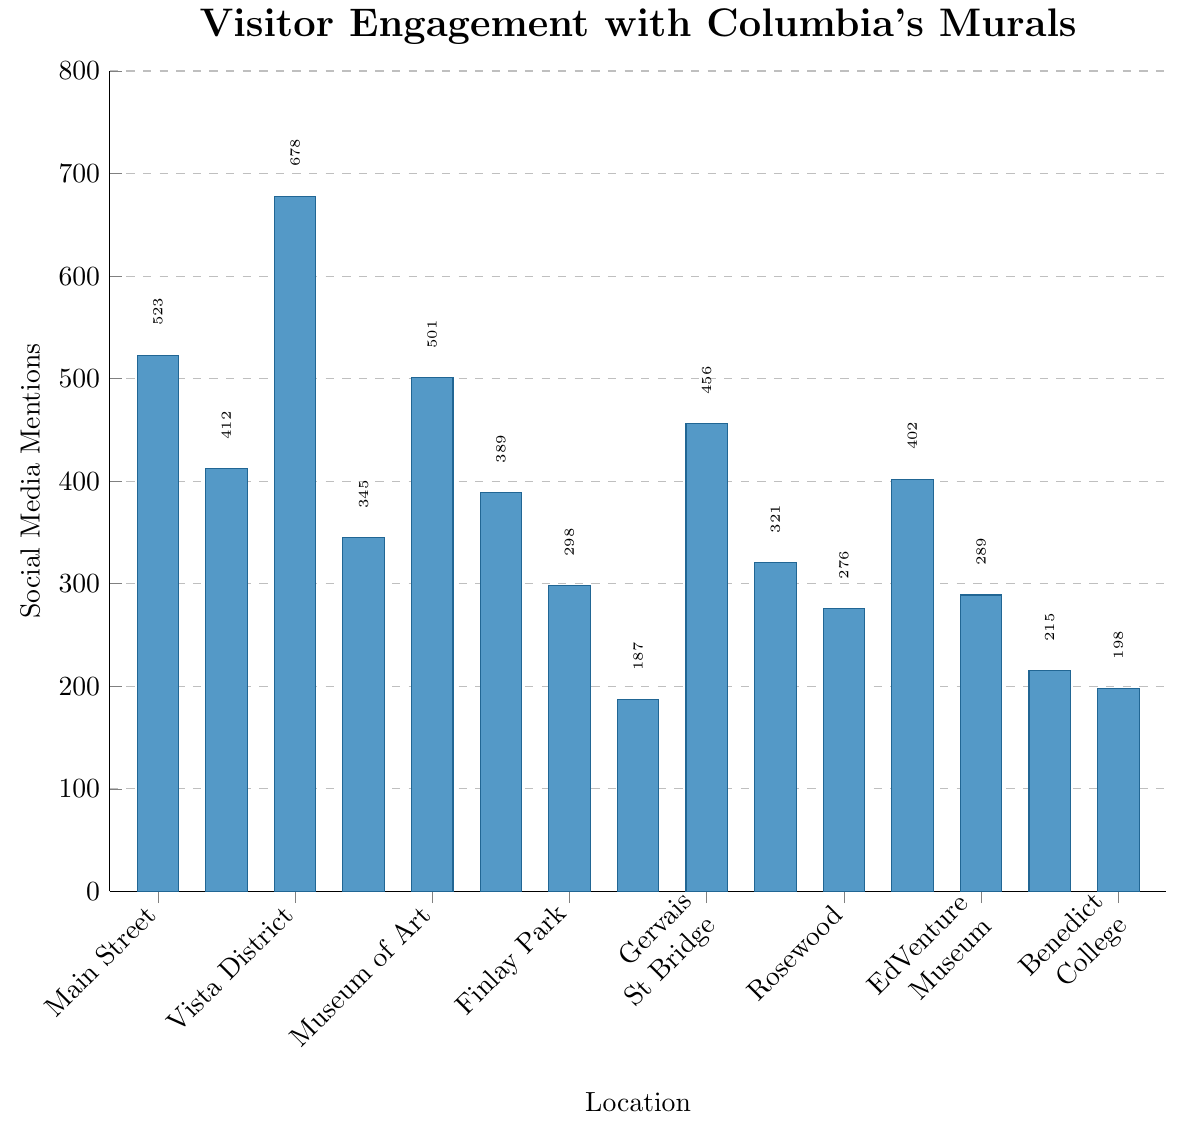what location has the highest number of social media mentions? The bar for Vista District Mural is the tallest, indicating that it has the highest number of mentions, which is 678.
Answer: Vista District Mural which location has the fewest social media mentions? The bar for Trenholm Plaza Public Art is the shortest, indicating that it has the fewest number of mentions, which is 187.
Answer: Trenholm Plaza Public Art what is the difference in social media mentions between the Main Street Mural and the Riverfront Park Installation? The number of mentions for Main Street Mural is 523 and for Riverfront Park Installation is 345. So, the difference is 523 - 345.
Answer: 178 which has more mentions, the EdVenture Children's Museum Exterior or Allen University Heritage Wall? By comparing the heights of the bars, EdVenture Children's Museum Exterior has 289 mentions, whereas Allen University Heritage Wall has 215 mentions. Thus, EdVenture Children's Museum Exterior has more mentions.
Answer: EdVenture Children's Museum Exterior what locations have more than 500 social media mentions? We can identify the locations with bars taller than the 500-mark on the y-axis. These are Main Street Mural (523), Vista District Mural (678), and Columbia Museum of Art Exterior (501).
Answer: Main Street Mural, Vista District Mural, Columbia Museum of Art Exterior how many mentions does the Devine Street Graffiti Wall have compared to the Rosewood Neighborhood Mural? The Devine Street Graffiti Wall has 321 mentions while the Rosewood Neighborhood Mural has 276 mentions. Comparing these values shows that Devine Street Graffiti Wall has more mentions.
Answer: Devine Street Graffiti Wall what is the average number of social media mentions across all locations? Sum all the mentions (523, 412, 678, 345, 501, 389, 298, 187, 456, 321, 276, 402, 289, 215, 198) and divide by the number of locations (15). The calculation is (523 + 412 + 678 + 345 + 501 + 389 + 298 + 187 + 456 + 321 + 276 + 402 + 289 + 215 + 198) / 15.
Answer: 372.2 how many locations have mentions between 300 and 500? Checking each location's mentions, the ones falling within this range are: Five Points Art Wall (412), Riverfront Park Installation (345), USC Campus Mural (389), Finlay Park Community Mural (298), Gervais Street Bridge Underpass (456), Devine Street Graffiti Wall (321), and State House Grounds Sculpture (402).
Answer: 7 is the social media engagement for the Columbia Museum of Art Exterior above or below 450? The Columbia Museum of Art Exterior has 501 mentions, which is above 450.
Answer: Above what is the total number of social media mentions for the murals on college campuses? Adding mentions from the USC Campus Mural (389), Allen University Heritage Wall (215), and Benedict College Unity Mural (198), the total is 389 + 215 + 198.
Answer: 802 